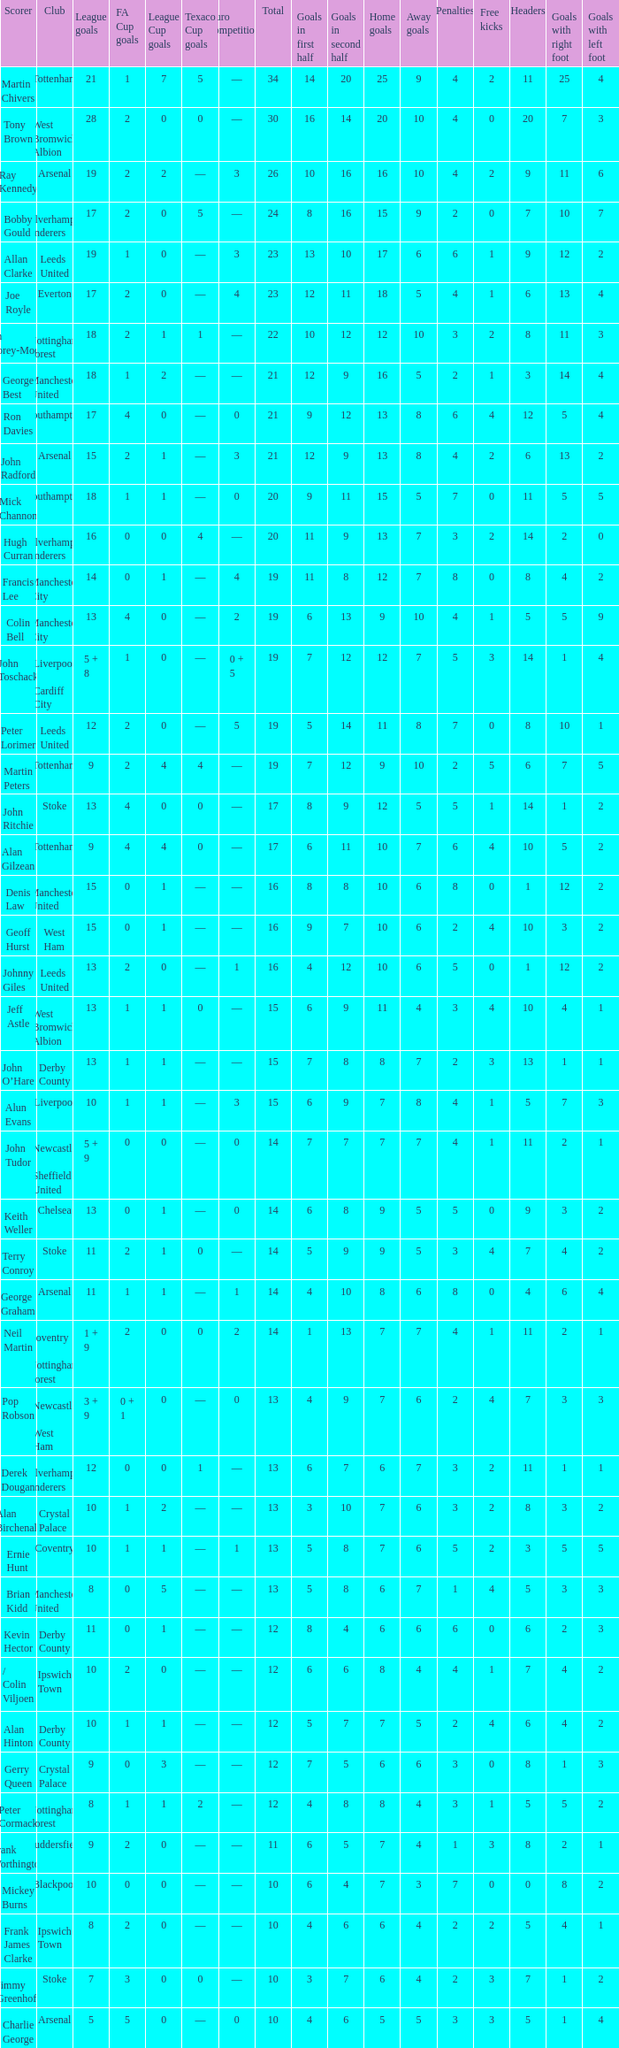What is the lowest League Cup Goals, when Scorer is Denis Law? 1.0. Could you parse the entire table? {'header': ['Scorer', 'Club', 'League goals', 'FA Cup goals', 'League Cup goals', 'Texaco Cup goals', 'Euro competitions', 'Total', 'Goals in first half', 'Goals in second half', 'Home goals', 'Away goals', 'Penalties', 'Free kicks', 'Headers', 'Goals with right foot', 'Goals with left foot'], 'rows': [['Martin Chivers', 'Tottenham', '21', '1', '7', '5', '—', '34', '14', '20', '25', '9', '4', '2', '11', '25', '4'], ['Tony Brown', 'West Bromwich Albion', '28', '2', '0', '0', '—', '30', '16', '14', '20', '10', '4', '0', '20', '7', '3'], ['Ray Kennedy', 'Arsenal', '19', '2', '2', '—', '3', '26', '10', '16', '16', '10', '4', '2', '9', '11', '6'], ['Bobby Gould', 'Wolverhampton Wanderers', '17', '2', '0', '5', '—', '24', '8', '16', '15', '9', '2', '0', '7', '10', '7'], ['Allan Clarke', 'Leeds United', '19', '1', '0', '—', '3', '23', '13', '10', '17', '6', '6', '1', '9', '12', '2'], ['Joe Royle', 'Everton', '17', '2', '0', '—', '4', '23', '12', '11', '18', '5', '4', '1', '6', '13', '4'], ['Ian Storey-Moore', 'Nottingham Forest', '18', '2', '1', '1', '—', '22', '10', '12', '12', '10', '3', '2', '8', '11', '3'], ['George Best', 'Manchester United', '18', '1', '2', '—', '—', '21', '12', '9', '16', '5', '2', '1', '3', '14', '4'], ['Ron Davies', 'Southampton', '17', '4', '0', '—', '0', '21', '9', '12', '13', '8', '6', '4', '12', '5', '4'], ['John Radford', 'Arsenal', '15', '2', '1', '—', '3', '21', '12', '9', '13', '8', '4', '2', '6', '13', '2'], ['Mick Channon', 'Southampton', '18', '1', '1', '—', '0', '20', '9', '11', '15', '5', '7', '0', '11', '5', '5'], ['Hugh Curran', 'Wolverhampton Wanderers', '16', '0', '0', '4', '—', '20', '11', '9', '13', '7', '3', '2', '14', '2', '0'], ['Francis Lee', 'Manchester City', '14', '0', '1', '—', '4', '19', '11', '8', '12', '7', '8', '0', '8', '4', '2'], ['Colin Bell', 'Manchester City', '13', '4', '0', '—', '2', '19', '6', '13', '9', '10', '4', '1', '5', '5', '9'], ['John Toschack', 'Liverpool / Cardiff City', '5 + 8', '1', '0', '—', '0 + 5', '19', '7', '12', '12', '7', '5', '3', '14', '1', '4'], ['Peter Lorimer', 'Leeds United', '12', '2', '0', '—', '5', '19', '5', '14', '11', '8', '7', '0', '8', '10', '1'], ['Martin Peters', 'Tottenham', '9', '2', '4', '4', '—', '19', '7', '12', '9', '10', '2', '5', '6', '7', '5'], ['John Ritchie', 'Stoke', '13', '4', '0', '0', '—', '17', '8', '9', '12', '5', '5', '1', '14', '1', '2'], ['Alan Gilzean', 'Tottenham', '9', '4', '4', '0', '—', '17', '6', '11', '10', '7', '6', '4', '10', '5', '2'], ['Denis Law', 'Manchester United', '15', '0', '1', '—', '—', '16', '8', '8', '10', '6', '8', '0', '1', '12', '2'], ['Geoff Hurst', 'West Ham', '15', '0', '1', '—', '—', '16', '9', '7', '10', '6', '2', '4', '10', '3', '2'], ['Johnny Giles', 'Leeds United', '13', '2', '0', '—', '1', '16', '4', '12', '10', '6', '5', '0', '1', '12', '2'], ['Jeff Astle', 'West Bromwich Albion', '13', '1', '1', '0', '—', '15', '6', '9', '11', '4', '3', '4', '10', '4', '1'], ['John O’Hare', 'Derby County', '13', '1', '1', '—', '—', '15', '7', '8', '8', '7', '2', '3', '13', '1', '1'], ['Alun Evans', 'Liverpool', '10', '1', '1', '—', '3', '15', '6', '9', '7', '8', '4', '1', '5', '7', '3'], ['John Tudor', 'Newcastle / Sheffield United', '5 + 9', '0', '0', '—', '0', '14', '7', '7', '7', '7', '4', '1', '11', '2', '1'], ['Keith Weller', 'Chelsea', '13', '0', '1', '—', '0', '14', '6', '8', '9', '5', '5', '0', '9', '3', '2'], ['Terry Conroy', 'Stoke', '11', '2', '1', '0', '—', '14', '5', '9', '9', '5', '3', '4', '7', '4', '2'], ['George Graham', 'Arsenal', '11', '1', '1', '—', '1', '14', '4', '10', '8', '6', '8', '0', '4', '6', '4'], ['Neil Martin', 'Coventry / Nottingham Forest', '1 + 9', '2', '0', '0', '2', '14', '1', '13', '7', '7', '4', '1', '11', '2', '1'], ['Pop Robson', 'Newcastle / West Ham', '3 + 9', '0 + 1', '0', '—', '0', '13', '4', '9', '7', '6', '2', '4', '7', '3', '3'], ['Derek Dougan', 'Wolverhampton Wanderers', '12', '0', '0', '1', '—', '13', '6', '7', '6', '7', '3', '2', '11', '1', '1'], ['Alan Birchenall', 'Crystal Palace', '10', '1', '2', '—', '—', '13', '3', '10', '7', '6', '3', '2', '8', '3', '2'], ['Ernie Hunt', 'Coventry', '10', '1', '1', '—', '1', '13', '5', '8', '7', '6', '5', '2', '3', '5', '5'], ['Brian Kidd', 'Manchester United', '8', '0', '5', '—', '—', '13', '5', '8', '6', '7', '1', '4', '5', '3', '3'], ['Kevin Hector', 'Derby County', '11', '0', '1', '—', '—', '12', '8', '4', '6', '6', '6', '0', '6', '2', '3'], ['/ Colin Viljoen', 'Ipswich Town', '10', '2', '0', '—', '—', '12', '6', '6', '8', '4', '4', '1', '7', '4', '2'], ['Alan Hinton', 'Derby County', '10', '1', '1', '—', '—', '12', '5', '7', '7', '5', '2', '4', '6', '4', '2'], ['Gerry Queen', 'Crystal Palace', '9', '0', '3', '—', '—', '12', '7', '5', '6', '6', '3', '0', '8', '1', '3'], ['Peter Cormack', 'Nottingham Forest', '8', '1', '1', '2', '—', '12', '4', '8', '8', '4', '3', '1', '5', '5', '2'], ['Frank Worthington', 'Huddersfield', '9', '2', '0', '—', '—', '11', '6', '5', '7', '4', '1', '3', '8', '2', '1'], ['Mickey Burns', 'Blackpool', '10', '0', '0', '—', '—', '10', '6', '4', '7', '3', '7', '0', '0', '8', '2'], ['Frank James Clarke', 'Ipswich Town', '8', '2', '0', '—', '—', '10', '4', '6', '6', '4', '2', '2', '5', '4', '1'], ['Jimmy Greenhoff', 'Stoke', '7', '3', '0', '0', '—', '10', '3', '7', '6', '4', '2', '3', '7', '1', '2'], ['Charlie George', 'Arsenal', '5', '5', '0', '—', '0', '10', '4', '6', '5', '5', '3', '3', '5', '1', '4']]} 